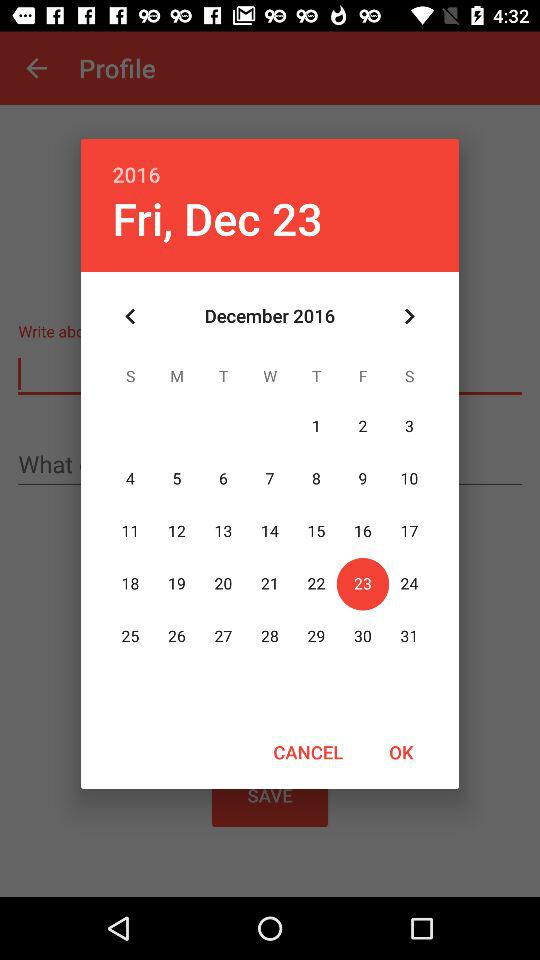What is the date mentioned? The mentioned date is Friday, December 23, 2016. 